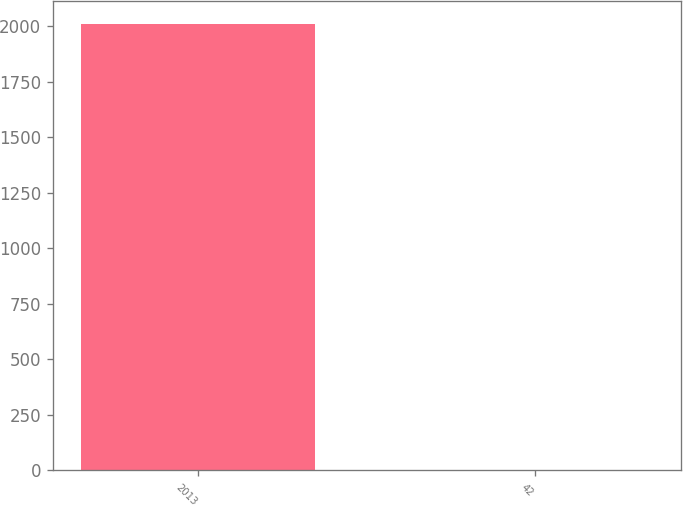<chart> <loc_0><loc_0><loc_500><loc_500><bar_chart><fcel>2013<fcel>42<nl><fcel>2012<fcel>3.2<nl></chart> 